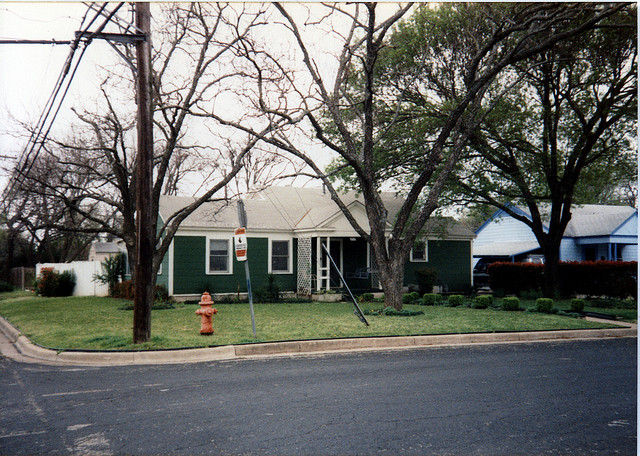How many cars are in the driveway? Upon reviewing the image, no cars are visible in the driveway, confirming the accuracy of the initially provided answer. 